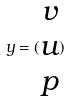Convert formula to latex. <formula><loc_0><loc_0><loc_500><loc_500>y = ( \begin{matrix} v \\ u \\ p \end{matrix} )</formula> 